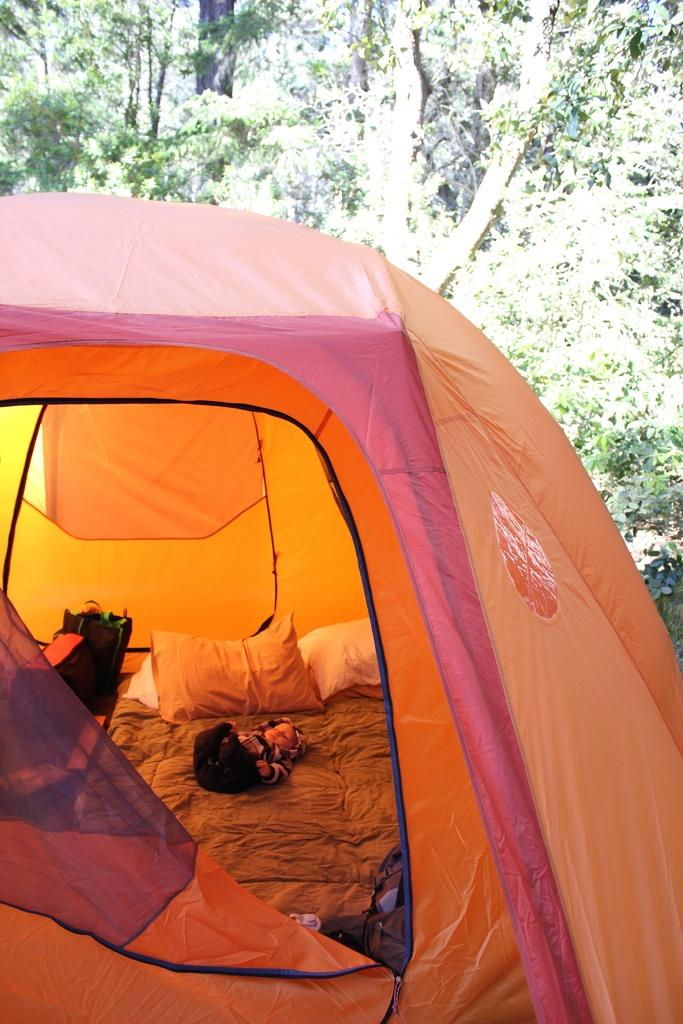What type of shelter is visible in the image? There is a camping tent in the image. What is inside the tent? There is a bed inside the tent. What can be seen on the bed? There are pillows on the bed. Who or what is on the bed? A baby is lying on the bed. What can be seen in the background of the image? There are many trees in the background of the image. What type of goat can be seen grazing near the tent in the image? There is no goat present in the image; it only features a camping tent, a bed, pillows, a baby, and trees in the background. 